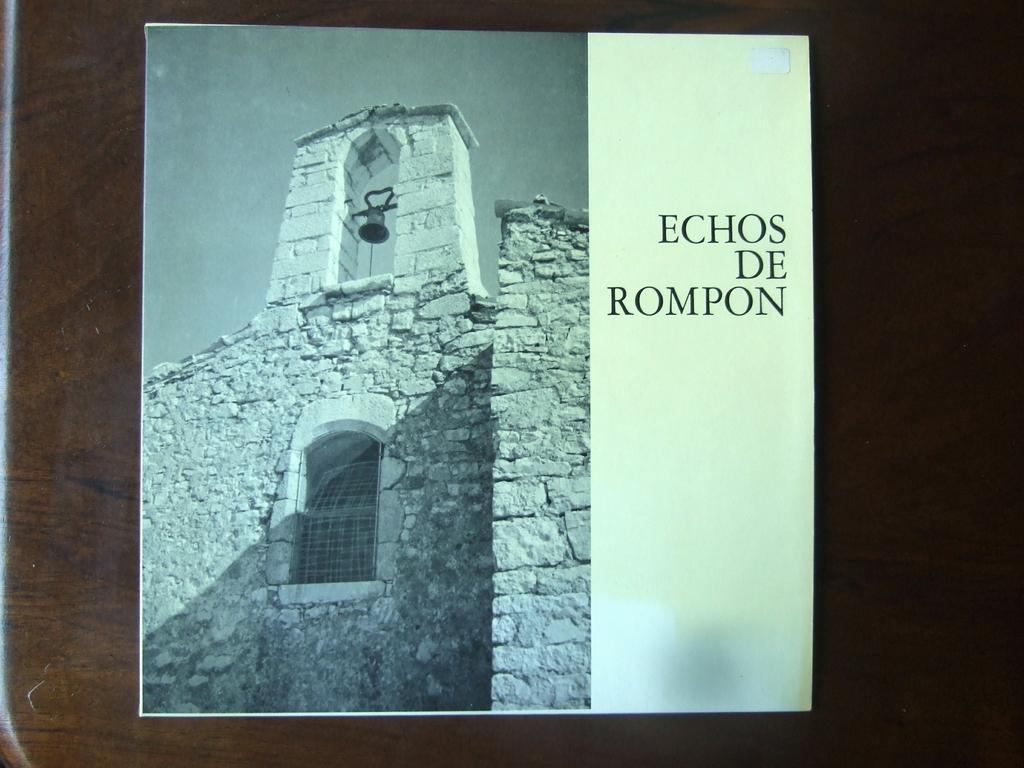<image>
Offer a succinct explanation of the picture presented. a building with echos de rompon on it 